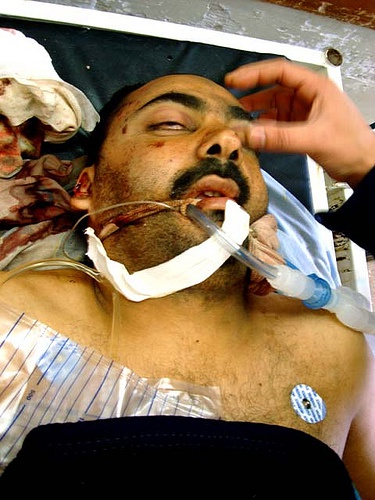Describe the objects in this image and their specific colors. I can see people in white, black, tan, olive, and ivory tones, bed in white, black, darkgray, and gray tones, and people in white, tan, black, and maroon tones in this image. 